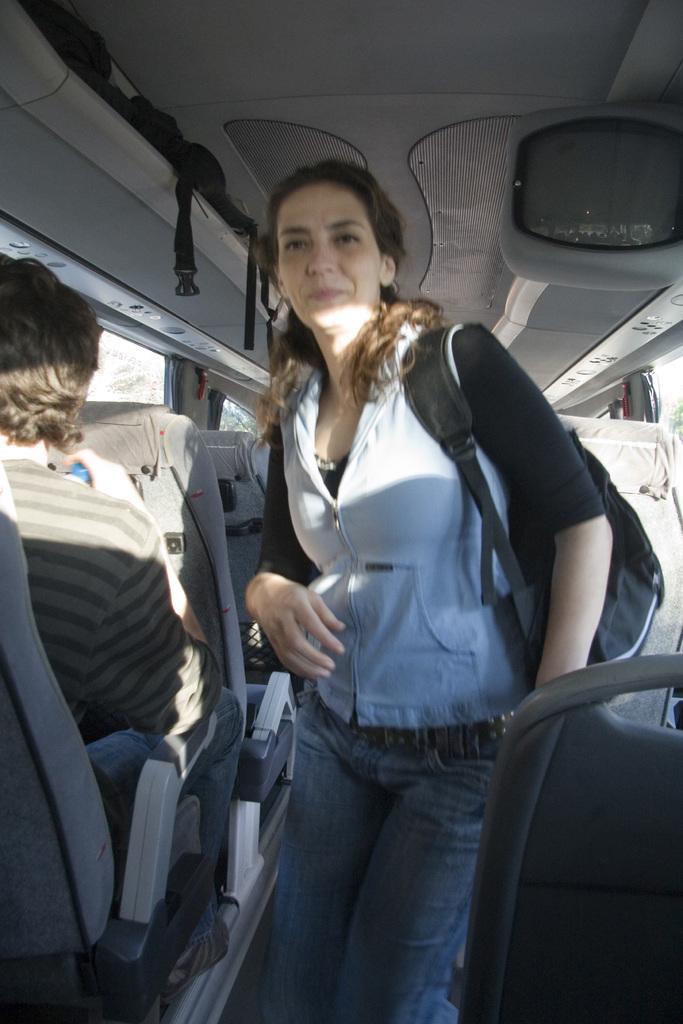Can you describe this image briefly? Picture inside of a vehicle. This person is sitting and this woman is standing. She wore a bag. This is television. 